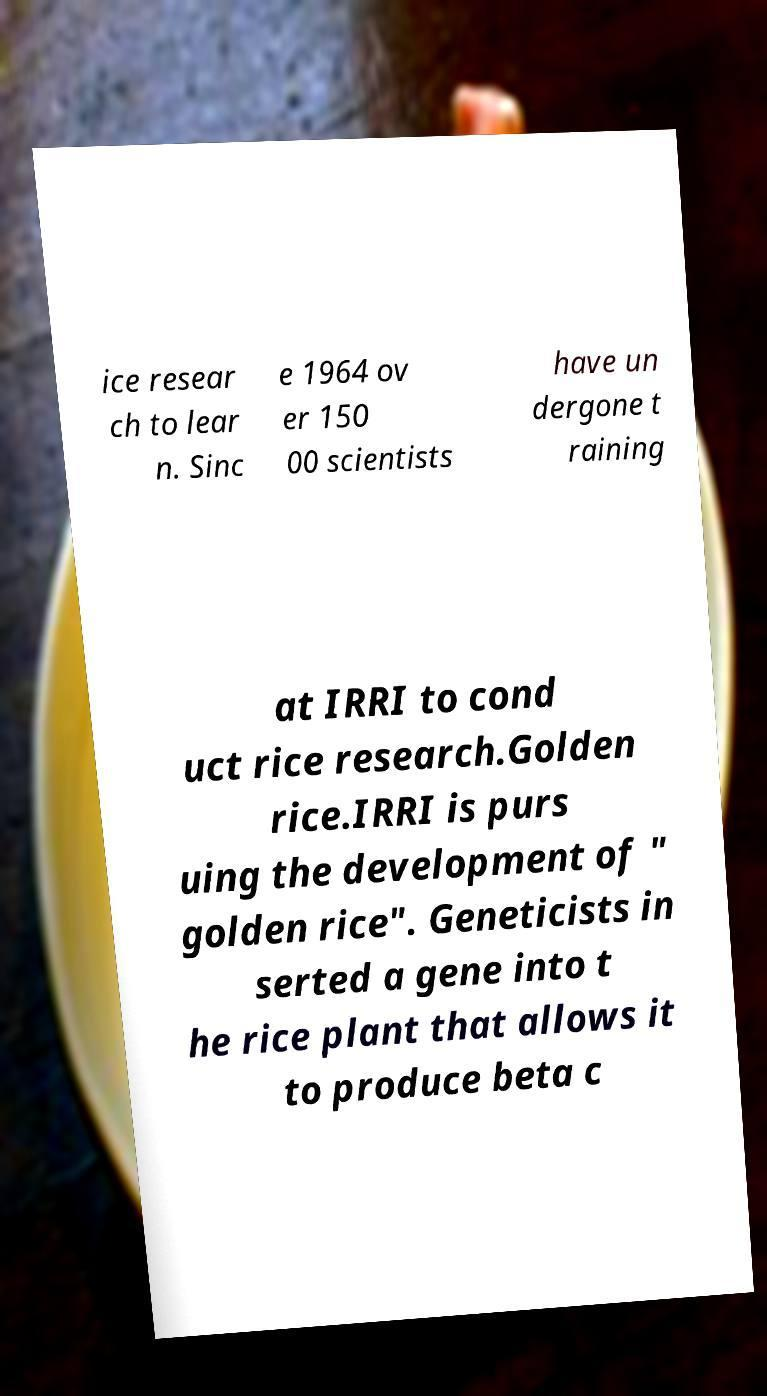Please identify and transcribe the text found in this image. ice resear ch to lear n. Sinc e 1964 ov er 150 00 scientists have un dergone t raining at IRRI to cond uct rice research.Golden rice.IRRI is purs uing the development of " golden rice". Geneticists in serted a gene into t he rice plant that allows it to produce beta c 